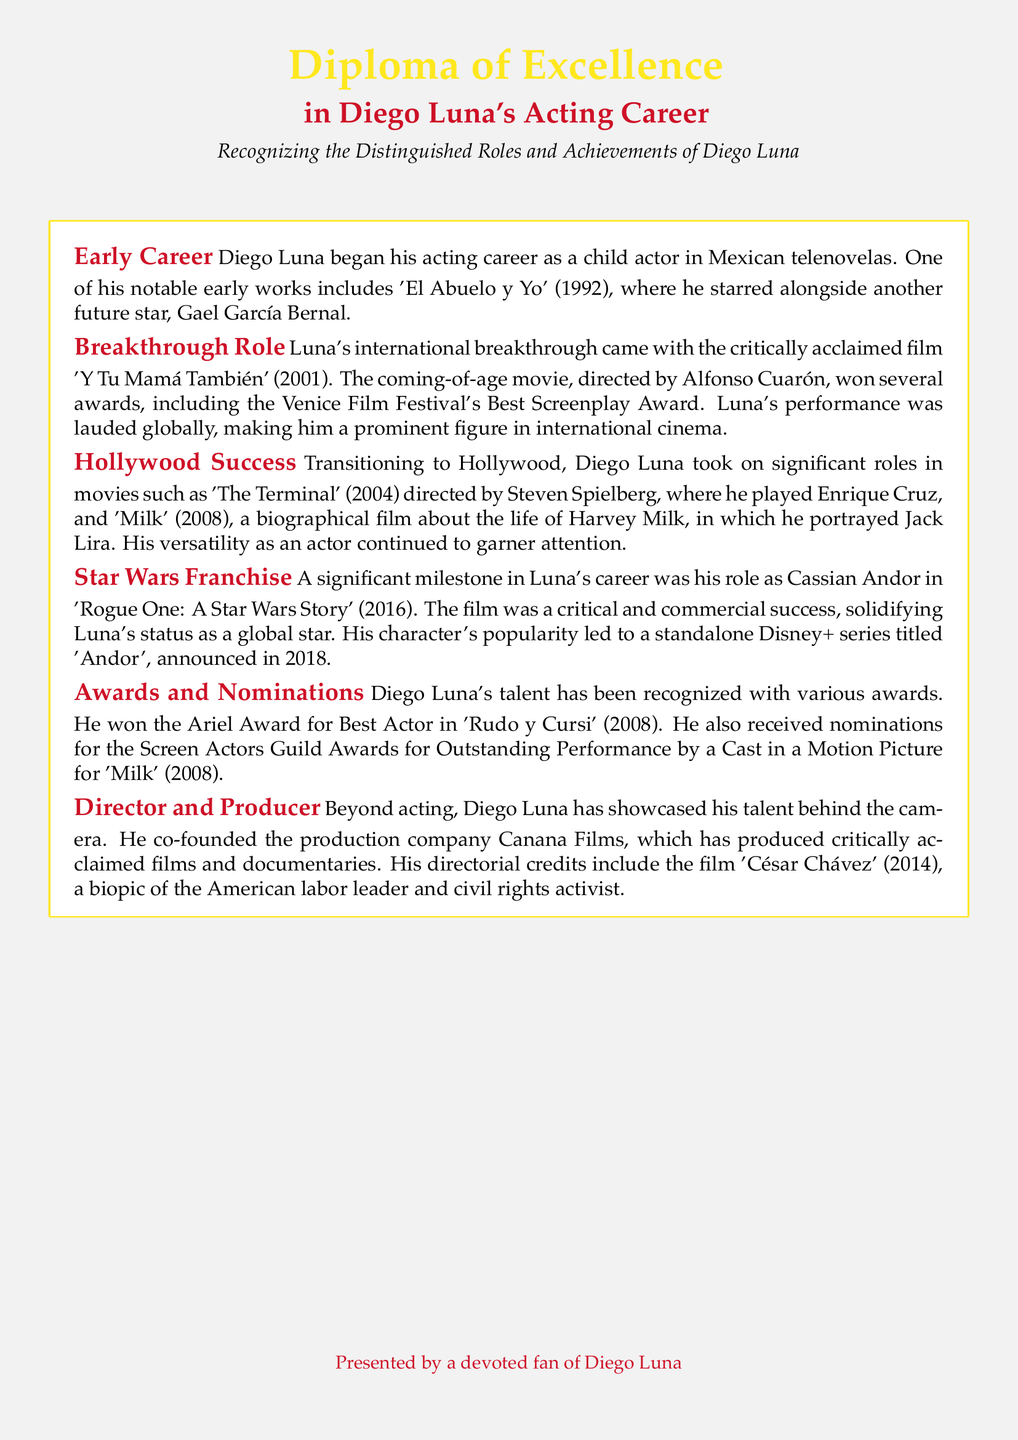What was Diego Luna's breakthrough role? The document states that Luna's international breakthrough came with the film 'Y Tu Mamá También' (2001).
Answer: 'Y Tu Mamá También' (2001) What award did Diego Luna win for 'Rudo y Cursi'? The document mentions that Luna won the Ariel Award for Best Actor in 'Rudo y Cursi' (2008).
Answer: Ariel Award for Best Actor In which film did Diego Luna play the character Jack Lira? According to the document, Diego Luna portrayed Jack Lira in the film 'Milk' (2008).
Answer: 'Milk' (2008) Which franchise did Diego Luna's character Cassian Andor belong to? The document specifies that Cassian Andor is a character in the 'Star Wars' franchise.
Answer: Star Wars What is the name of the production company co-founded by Diego Luna? The document states that he co-founded the production company Canana Films.
Answer: Canana Films What year was the film 'César Chávez' released? The document indicates that 'César Chávez' was released in 2014.
Answer: 2014 What was Diego Luna's role in 'Rogue One: A Star Wars Story'? The document describes his role in 'Rogue One' as Cassian Andor.
Answer: Cassian Andor Which director was behind 'Y Tu Mamá También'? The document cites Alfonso Cuarón as the director of 'Y Tu Mamá También'.
Answer: Alfonso Cuarón What is the primary focus of this diploma? The document highlights the recognition of Diego Luna's distinguished roles and achievements.
Answer: Diego Luna's distinguished roles and achievements 